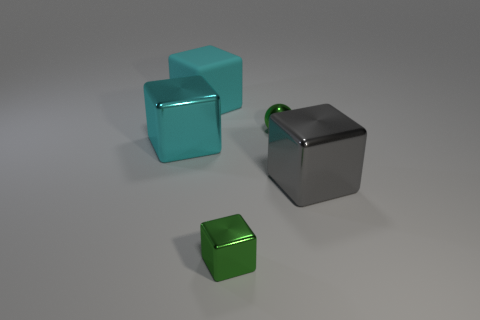Subtract 1 cubes. How many cubes are left? 3 Add 5 green balls. How many objects exist? 10 Subtract all cubes. How many objects are left? 1 Add 4 big green shiny cylinders. How many big green shiny cylinders exist? 4 Subtract 0 yellow cubes. How many objects are left? 5 Subtract all metallic balls. Subtract all green shiny cubes. How many objects are left? 3 Add 2 matte things. How many matte things are left? 3 